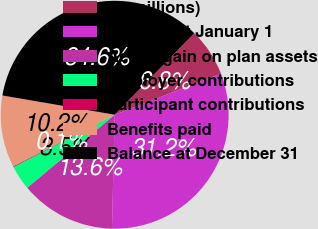Convert chart. <chart><loc_0><loc_0><loc_500><loc_500><pie_chart><fcel>(In millions)<fcel>Balance at January 1<fcel>Actual gain on plan assets<fcel>Employer contributions<fcel>Participant contributions<fcel>Benefits paid<fcel>Balance at December 31<nl><fcel>6.83%<fcel>31.24%<fcel>13.56%<fcel>3.47%<fcel>0.11%<fcel>10.19%<fcel>34.6%<nl></chart> 